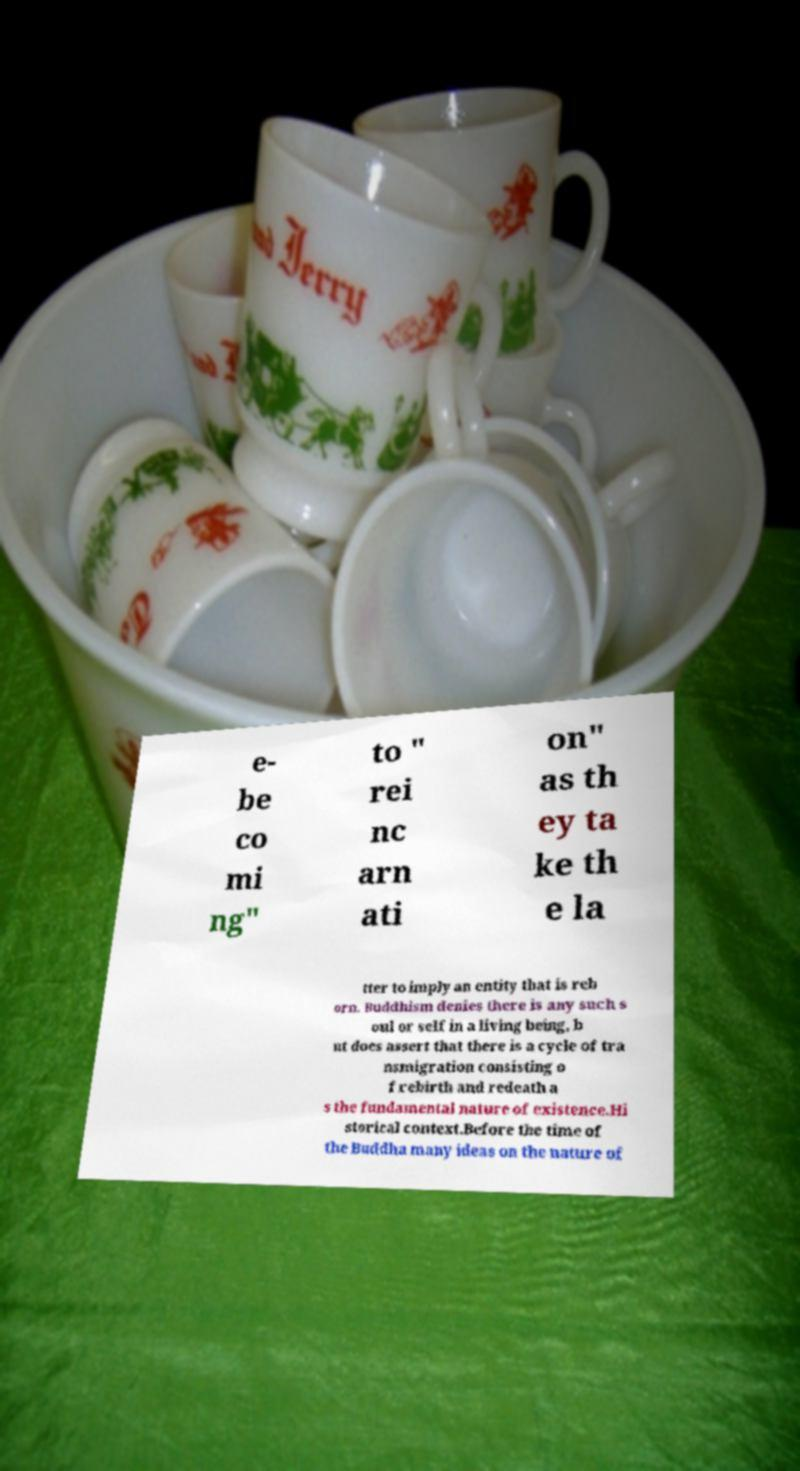There's text embedded in this image that I need extracted. Can you transcribe it verbatim? e- be co mi ng" to " rei nc arn ati on" as th ey ta ke th e la tter to imply an entity that is reb orn. Buddhism denies there is any such s oul or self in a living being, b ut does assert that there is a cycle of tra nsmigration consisting o f rebirth and redeath a s the fundamental nature of existence.Hi storical context.Before the time of the Buddha many ideas on the nature of 